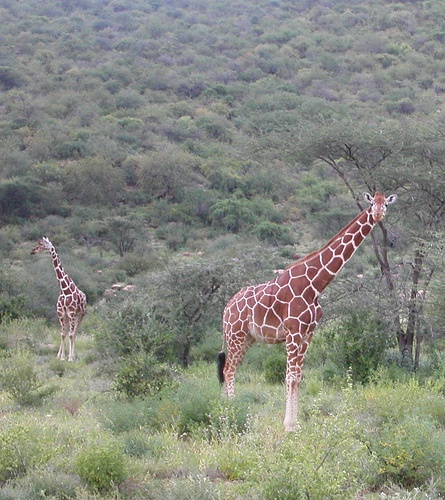Describe the objects in this image and their specific colors. I can see giraffe in darkgray, brown, and lightgray tones and giraffe in darkgray, gray, and lightgray tones in this image. 